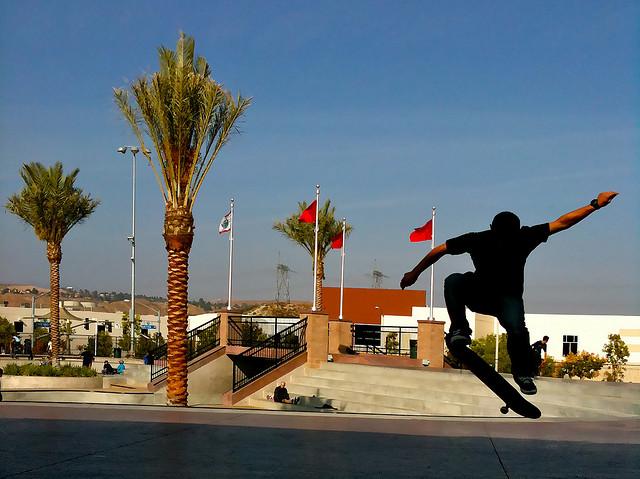What kind of trees are in the picture?
Concise answer only. Palm. What part of the skateboarder is touching the skateboard?
Keep it brief. Foot. What color is the skateboarders shirt?
Quick response, please. Black. What color baseball cap is this person wearing?
Give a very brief answer. Black. What sport is depicted?
Be succinct. Skateboarding. Is this person balanced?
Keep it brief. Yes. Why is there a cement wall against the side of the road?
Keep it brief. Overpass. Are these trimmed palm trees?
Quick response, please. Yes. 